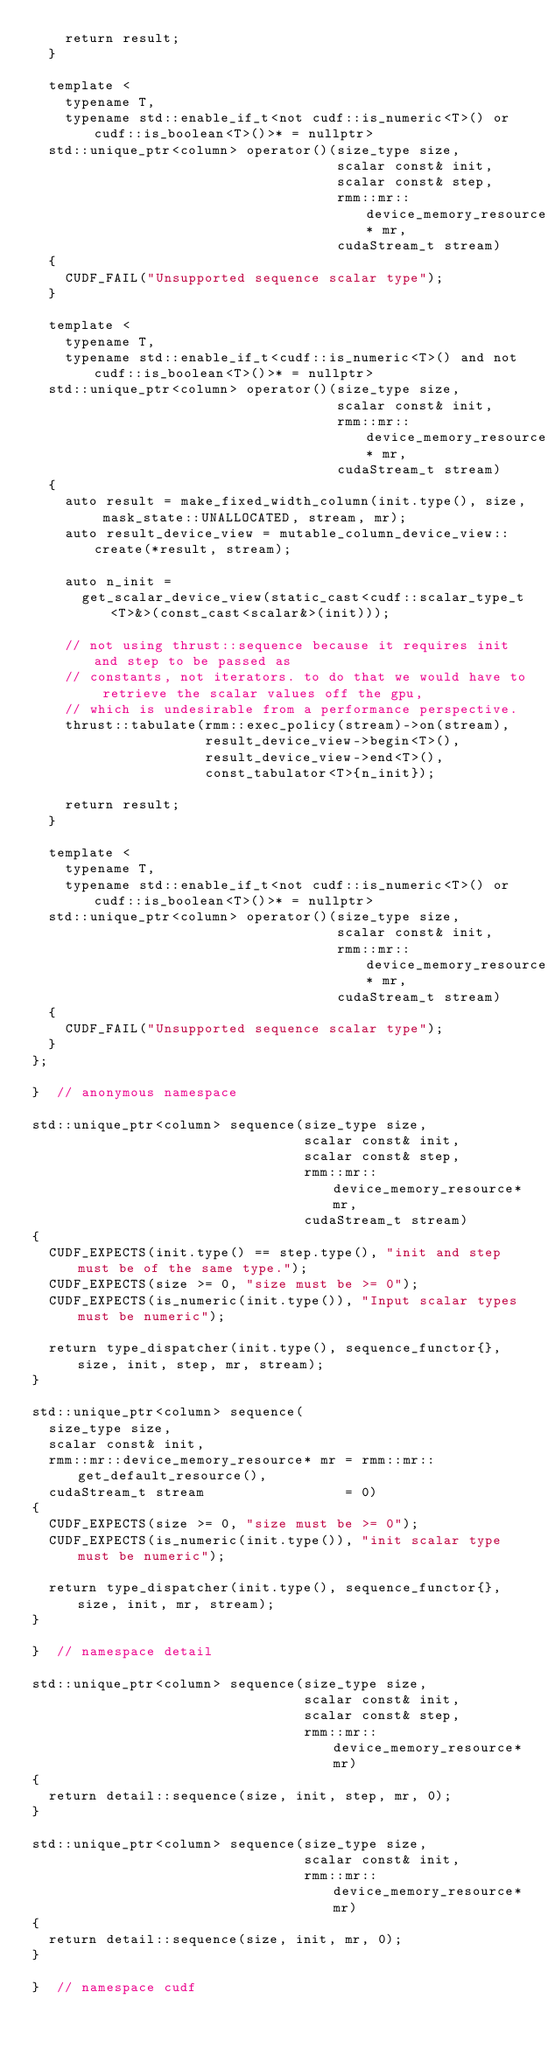<code> <loc_0><loc_0><loc_500><loc_500><_Cuda_>    return result;
  }

  template <
    typename T,
    typename std::enable_if_t<not cudf::is_numeric<T>() or cudf::is_boolean<T>()>* = nullptr>
  std::unique_ptr<column> operator()(size_type size,
                                     scalar const& init,
                                     scalar const& step,
                                     rmm::mr::device_memory_resource* mr,
                                     cudaStream_t stream)
  {
    CUDF_FAIL("Unsupported sequence scalar type");
  }

  template <
    typename T,
    typename std::enable_if_t<cudf::is_numeric<T>() and not cudf::is_boolean<T>()>* = nullptr>
  std::unique_ptr<column> operator()(size_type size,
                                     scalar const& init,
                                     rmm::mr::device_memory_resource* mr,
                                     cudaStream_t stream)
  {
    auto result = make_fixed_width_column(init.type(), size, mask_state::UNALLOCATED, stream, mr);
    auto result_device_view = mutable_column_device_view::create(*result, stream);

    auto n_init =
      get_scalar_device_view(static_cast<cudf::scalar_type_t<T>&>(const_cast<scalar&>(init)));

    // not using thrust::sequence because it requires init and step to be passed as
    // constants, not iterators. to do that we would have to retrieve the scalar values off the gpu,
    // which is undesirable from a performance perspective.
    thrust::tabulate(rmm::exec_policy(stream)->on(stream),
                     result_device_view->begin<T>(),
                     result_device_view->end<T>(),
                     const_tabulator<T>{n_init});

    return result;
  }

  template <
    typename T,
    typename std::enable_if_t<not cudf::is_numeric<T>() or cudf::is_boolean<T>()>* = nullptr>
  std::unique_ptr<column> operator()(size_type size,
                                     scalar const& init,
                                     rmm::mr::device_memory_resource* mr,
                                     cudaStream_t stream)
  {
    CUDF_FAIL("Unsupported sequence scalar type");
  }
};

}  // anonymous namespace

std::unique_ptr<column> sequence(size_type size,
                                 scalar const& init,
                                 scalar const& step,
                                 rmm::mr::device_memory_resource* mr,
                                 cudaStream_t stream)
{
  CUDF_EXPECTS(init.type() == step.type(), "init and step must be of the same type.");
  CUDF_EXPECTS(size >= 0, "size must be >= 0");
  CUDF_EXPECTS(is_numeric(init.type()), "Input scalar types must be numeric");

  return type_dispatcher(init.type(), sequence_functor{}, size, init, step, mr, stream);
}

std::unique_ptr<column> sequence(
  size_type size,
  scalar const& init,
  rmm::mr::device_memory_resource* mr = rmm::mr::get_default_resource(),
  cudaStream_t stream                 = 0)
{
  CUDF_EXPECTS(size >= 0, "size must be >= 0");
  CUDF_EXPECTS(is_numeric(init.type()), "init scalar type must be numeric");

  return type_dispatcher(init.type(), sequence_functor{}, size, init, mr, stream);
}

}  // namespace detail

std::unique_ptr<column> sequence(size_type size,
                                 scalar const& init,
                                 scalar const& step,
                                 rmm::mr::device_memory_resource* mr)
{
  return detail::sequence(size, init, step, mr, 0);
}

std::unique_ptr<column> sequence(size_type size,
                                 scalar const& init,
                                 rmm::mr::device_memory_resource* mr)
{
  return detail::sequence(size, init, mr, 0);
}

}  // namespace cudf
</code> 